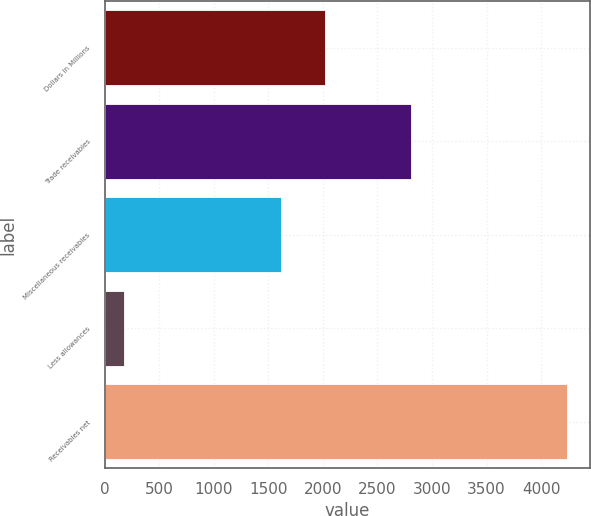Convert chart to OTSL. <chart><loc_0><loc_0><loc_500><loc_500><bar_chart><fcel>Dollars in Millions<fcel>Trade receivables<fcel>Miscellaneous receivables<fcel>Less allowances<fcel>Receivables net<nl><fcel>2021<fcel>2805<fcel>1615<fcel>180<fcel>4240<nl></chart> 